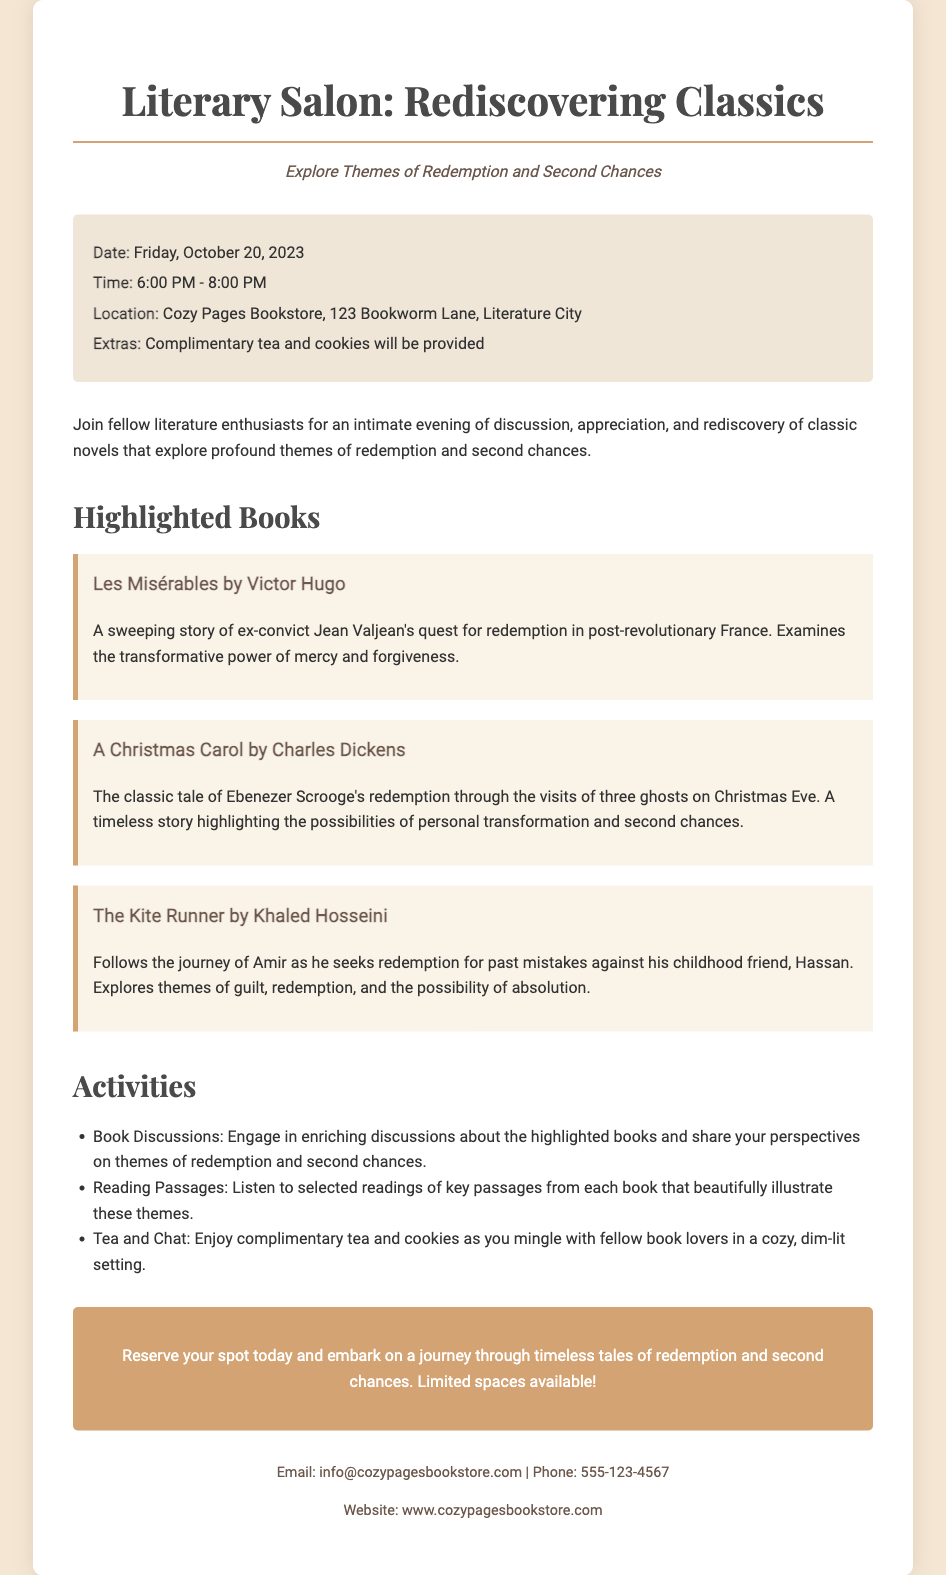What is the date of the event? The date of the event is explicitly stated in the document as Friday, October 20, 2023.
Answer: Friday, October 20, 2023 What time does the event start? The start time of the event is mentioned in the event details section as 6:00 PM.
Answer: 6:00 PM Where is the event being held? The location of the event is provided in the document as Cozy Pages Bookstore, 123 Bookworm Lane, Literature City.
Answer: Cozy Pages Bookstore, 123 Bookworm Lane, Literature City Name one of the highlighted books. The document lists several highlighted books; one example is Les Misérables by Victor Hugo.
Answer: Les Misérables by Victor Hugo What theme do the highlighted books explore? The document specifies that the highlighted books explore the themes of redemption and second chances.
Answer: Redemption and second chances How long is the event scheduled to last? The duration of the event is stated as from 6:00 PM to 8:00 PM, which is 2 hours long.
Answer: 2 hours What extras will be provided during the event? The document states that complimentary tea and cookies will be provided during the event.
Answer: Complimentary tea and cookies What type of activity involves listening to passages? The document mentions that one of the activities is called Reading Passages, where selected readings are listened to.
Answer: Reading Passages How can you reserve a spot for the event? The document encourages participants to reserve their spot directly, implying a contact method is available, typically by email or phone listed below.
Answer: By emailing or calling the provided contact information 